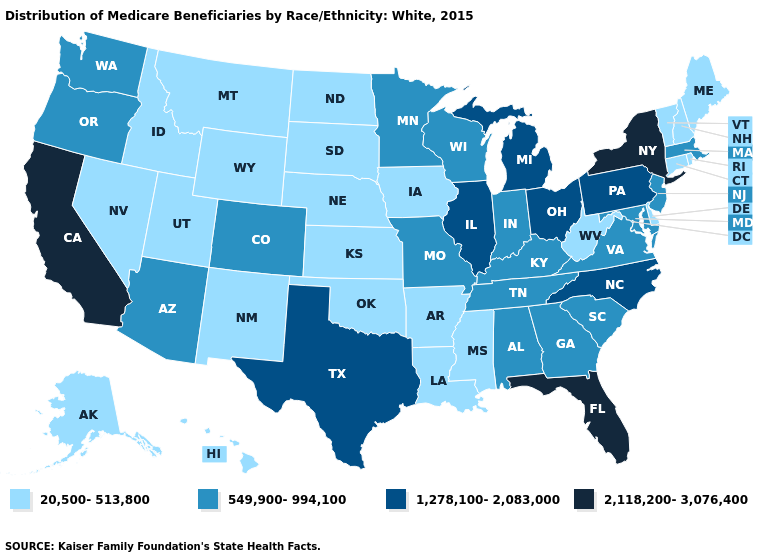What is the value of Rhode Island?
Answer briefly. 20,500-513,800. Is the legend a continuous bar?
Keep it brief. No. What is the highest value in states that border Colorado?
Quick response, please. 549,900-994,100. How many symbols are there in the legend?
Quick response, please. 4. Does Massachusetts have the lowest value in the Northeast?
Short answer required. No. What is the highest value in the USA?
Quick response, please. 2,118,200-3,076,400. What is the value of New York?
Answer briefly. 2,118,200-3,076,400. Does the map have missing data?
Write a very short answer. No. Name the states that have a value in the range 20,500-513,800?
Answer briefly. Alaska, Arkansas, Connecticut, Delaware, Hawaii, Idaho, Iowa, Kansas, Louisiana, Maine, Mississippi, Montana, Nebraska, Nevada, New Hampshire, New Mexico, North Dakota, Oklahoma, Rhode Island, South Dakota, Utah, Vermont, West Virginia, Wyoming. Among the states that border Nebraska , does South Dakota have the highest value?
Keep it brief. No. What is the value of Montana?
Quick response, please. 20,500-513,800. What is the value of Pennsylvania?
Write a very short answer. 1,278,100-2,083,000. Does the map have missing data?
Answer briefly. No. Does Nebraska have the lowest value in the USA?
Answer briefly. Yes. 